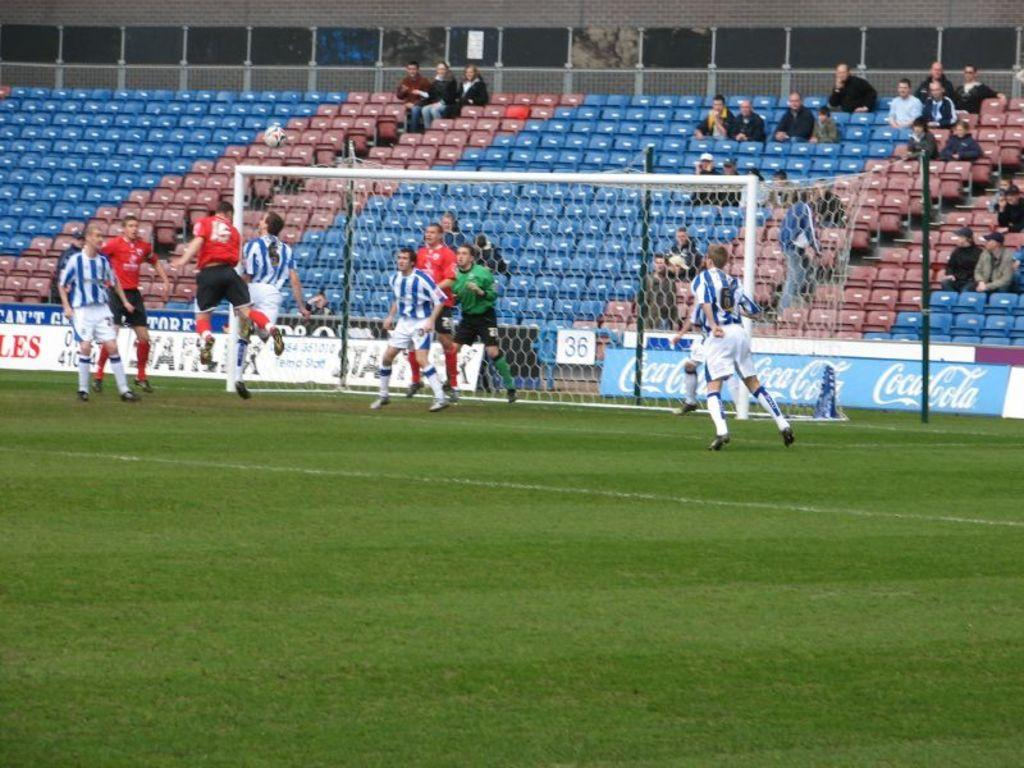<image>
Provide a brief description of the given image. Soccer Field with two teams playing against each other, Coca Cola sign on the backboard. 